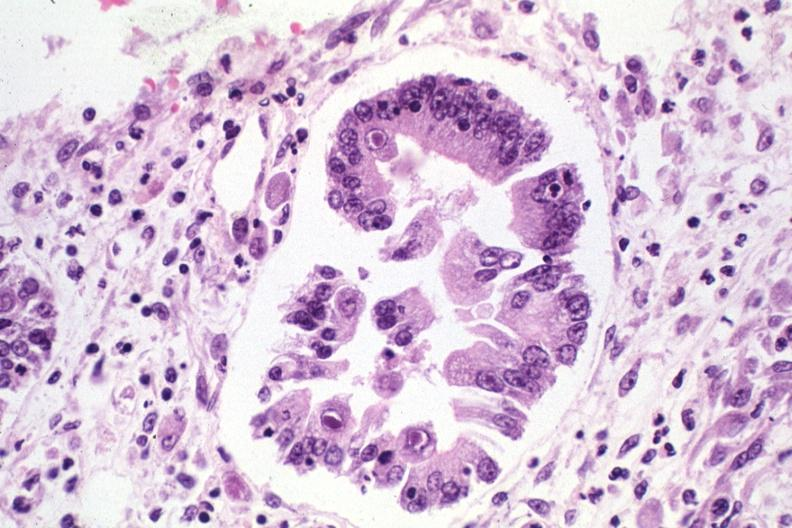does this image show inclusion bodies?
Answer the question using a single word or phrase. Yes 